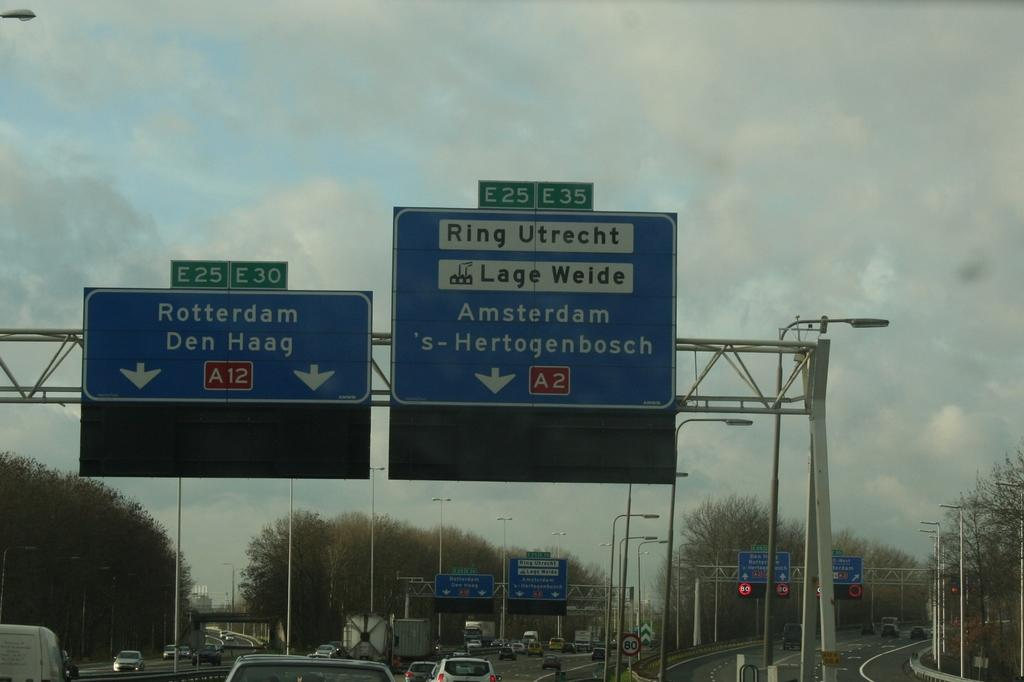<image>
Create a compact narrative representing the image presented. A blue sign shows the way towards Rotterdam and Den Haag 